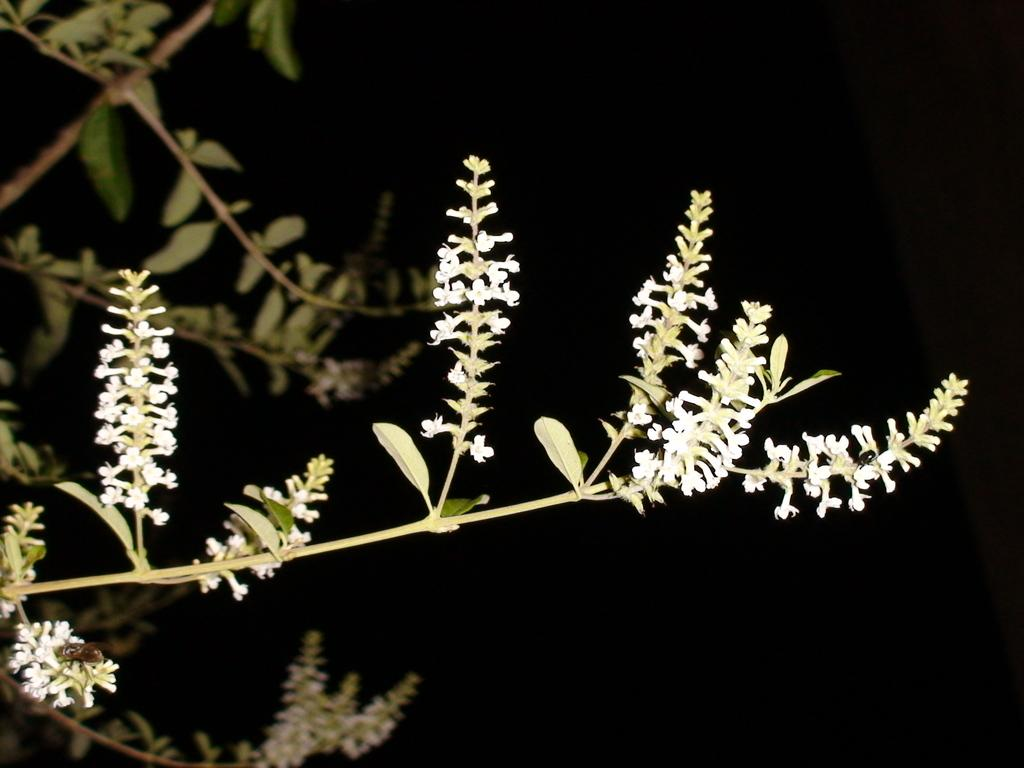What type of living organism can be seen in the image? There is a plant in the image. What specific features can be observed on the plant? The plant has small flowers. What is the color of the background in the image? The background of the image is dark. Where are the leaves located on the plant in the image? There are leaves visible on the left side of the image. Is there a parcel being delivered in the bedroom in the image? There is no mention of a parcel or a bedroom in the image; it features a plant with small flowers and a dark background. 